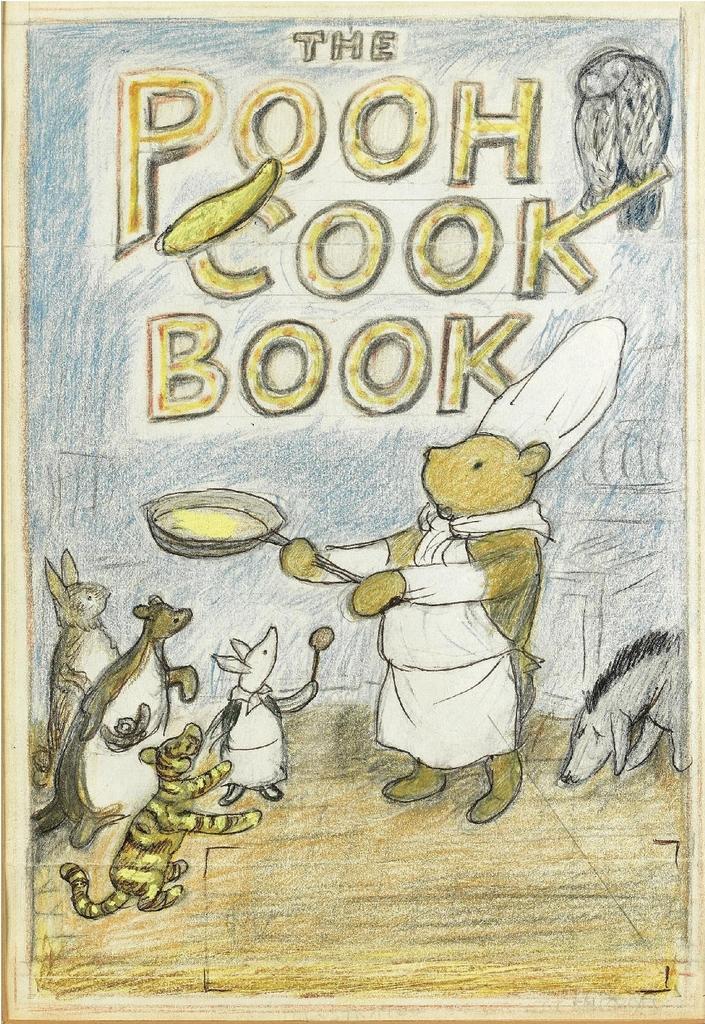Can you describe this image briefly? In this image we can see drawings of animals and some text. 